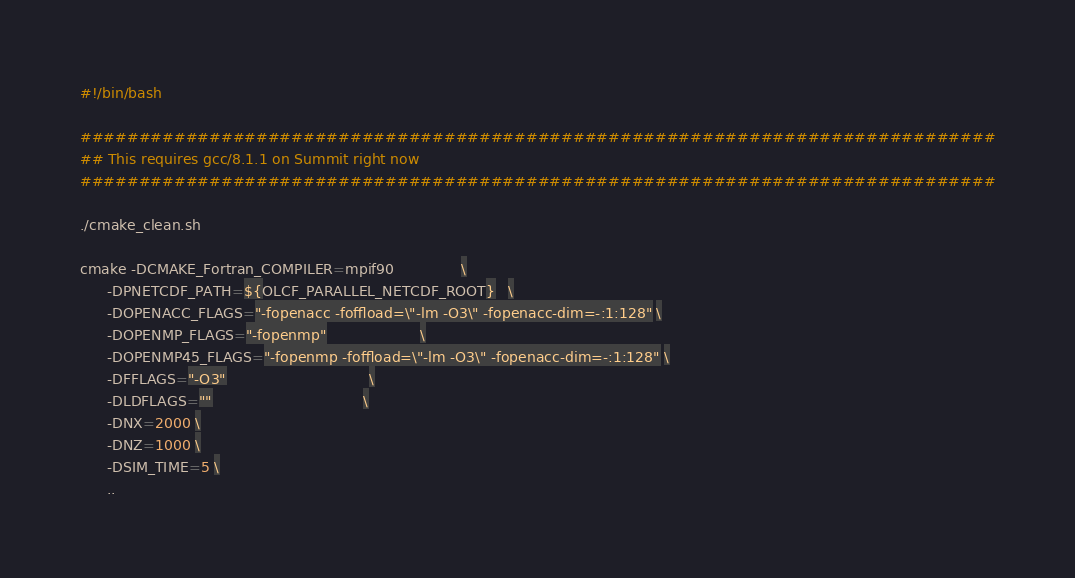<code> <loc_0><loc_0><loc_500><loc_500><_Bash_>#!/bin/bash

##############################################################################
## This requires gcc/8.1.1 on Summit right now
##############################################################################

./cmake_clean.sh

cmake -DCMAKE_Fortran_COMPILER=mpif90               \
      -DPNETCDF_PATH=${OLCF_PARALLEL_NETCDF_ROOT}   \
      -DOPENACC_FLAGS="-fopenacc -foffload=\"-lm -O3\" -fopenacc-dim=-:1:128" \
      -DOPENMP_FLAGS="-fopenmp"                     \
      -DOPENMP45_FLAGS="-fopenmp -foffload=\"-lm -O3\" -fopenacc-dim=-:1:128" \
      -DFFLAGS="-O3"                                \
      -DLDFLAGS=""                                  \
      -DNX=2000 \
      -DNZ=1000 \
      -DSIM_TIME=5 \
      ..

</code> 